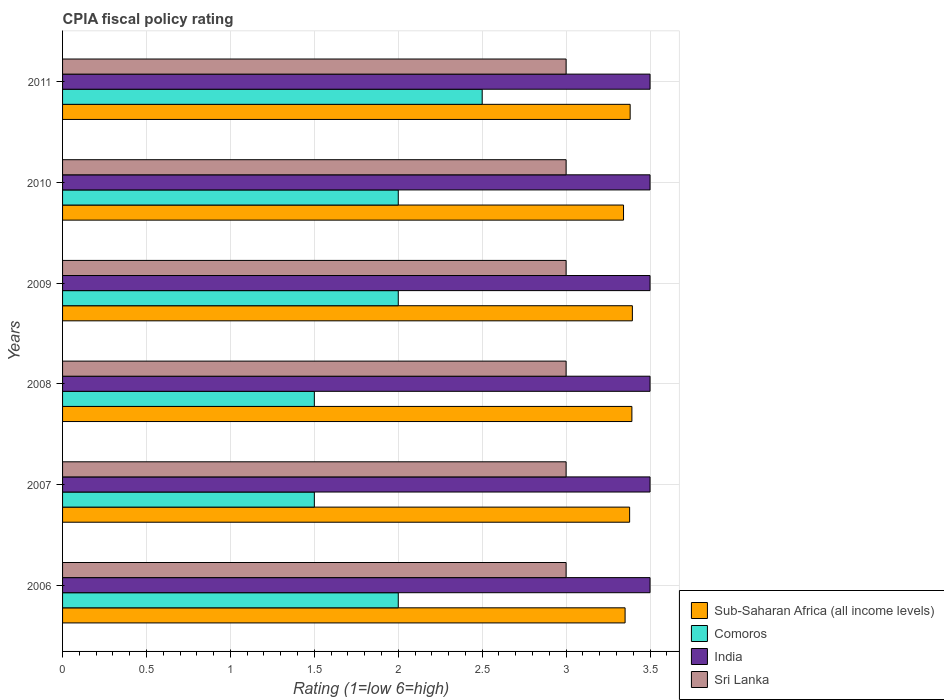Are the number of bars on each tick of the Y-axis equal?
Your response must be concise. Yes. How many bars are there on the 6th tick from the top?
Your answer should be very brief. 4. What is the CPIA rating in Sub-Saharan Africa (all income levels) in 2006?
Offer a very short reply. 3.35. Across all years, what is the minimum CPIA rating in Sri Lanka?
Provide a short and direct response. 3. What is the difference between the CPIA rating in Sri Lanka in 2007 and that in 2010?
Your response must be concise. 0. What is the difference between the CPIA rating in India in 2011 and the CPIA rating in Comoros in 2007?
Provide a succinct answer. 2. In the year 2011, what is the difference between the CPIA rating in Sub-Saharan Africa (all income levels) and CPIA rating in Sri Lanka?
Make the answer very short. 0.38. In how many years, is the CPIA rating in India greater than 0.30000000000000004 ?
Keep it short and to the point. 6. What is the ratio of the CPIA rating in Sri Lanka in 2008 to that in 2011?
Make the answer very short. 1. Is the CPIA rating in Sri Lanka in 2006 less than that in 2009?
Keep it short and to the point. No. What is the difference between the highest and the lowest CPIA rating in Sri Lanka?
Provide a succinct answer. 0. Is the sum of the CPIA rating in Sub-Saharan Africa (all income levels) in 2006 and 2007 greater than the maximum CPIA rating in Sri Lanka across all years?
Your answer should be compact. Yes. What does the 3rd bar from the top in 2006 represents?
Ensure brevity in your answer.  Comoros. What does the 4th bar from the bottom in 2009 represents?
Make the answer very short. Sri Lanka. Is it the case that in every year, the sum of the CPIA rating in Sri Lanka and CPIA rating in Comoros is greater than the CPIA rating in Sub-Saharan Africa (all income levels)?
Offer a very short reply. Yes. Are all the bars in the graph horizontal?
Your response must be concise. Yes. How many years are there in the graph?
Ensure brevity in your answer.  6. Where does the legend appear in the graph?
Your answer should be compact. Bottom right. How many legend labels are there?
Give a very brief answer. 4. What is the title of the graph?
Provide a succinct answer. CPIA fiscal policy rating. What is the label or title of the Y-axis?
Ensure brevity in your answer.  Years. What is the Rating (1=low 6=high) of Sub-Saharan Africa (all income levels) in 2006?
Give a very brief answer. 3.35. What is the Rating (1=low 6=high) of India in 2006?
Your response must be concise. 3.5. What is the Rating (1=low 6=high) of Sri Lanka in 2006?
Give a very brief answer. 3. What is the Rating (1=low 6=high) of Sub-Saharan Africa (all income levels) in 2007?
Keep it short and to the point. 3.38. What is the Rating (1=low 6=high) of Comoros in 2007?
Your answer should be compact. 1.5. What is the Rating (1=low 6=high) in India in 2007?
Ensure brevity in your answer.  3.5. What is the Rating (1=low 6=high) of Sri Lanka in 2007?
Provide a succinct answer. 3. What is the Rating (1=low 6=high) in Sub-Saharan Africa (all income levels) in 2008?
Your response must be concise. 3.39. What is the Rating (1=low 6=high) in Sub-Saharan Africa (all income levels) in 2009?
Keep it short and to the point. 3.39. What is the Rating (1=low 6=high) of Comoros in 2009?
Ensure brevity in your answer.  2. What is the Rating (1=low 6=high) of Sub-Saharan Africa (all income levels) in 2010?
Ensure brevity in your answer.  3.34. What is the Rating (1=low 6=high) in India in 2010?
Offer a terse response. 3.5. What is the Rating (1=low 6=high) of Sri Lanka in 2010?
Your answer should be compact. 3. What is the Rating (1=low 6=high) in Sub-Saharan Africa (all income levels) in 2011?
Your answer should be compact. 3.38. What is the Rating (1=low 6=high) of Comoros in 2011?
Offer a very short reply. 2.5. What is the Rating (1=low 6=high) in Sri Lanka in 2011?
Ensure brevity in your answer.  3. Across all years, what is the maximum Rating (1=low 6=high) in Sub-Saharan Africa (all income levels)?
Offer a terse response. 3.39. Across all years, what is the maximum Rating (1=low 6=high) of Sri Lanka?
Provide a short and direct response. 3. Across all years, what is the minimum Rating (1=low 6=high) of Sub-Saharan Africa (all income levels)?
Ensure brevity in your answer.  3.34. Across all years, what is the minimum Rating (1=low 6=high) in Comoros?
Your answer should be very brief. 1.5. What is the total Rating (1=low 6=high) in Sub-Saharan Africa (all income levels) in the graph?
Your response must be concise. 20.24. What is the total Rating (1=low 6=high) of India in the graph?
Ensure brevity in your answer.  21. What is the difference between the Rating (1=low 6=high) of Sub-Saharan Africa (all income levels) in 2006 and that in 2007?
Your response must be concise. -0.03. What is the difference between the Rating (1=low 6=high) in Comoros in 2006 and that in 2007?
Ensure brevity in your answer.  0.5. What is the difference between the Rating (1=low 6=high) of Sub-Saharan Africa (all income levels) in 2006 and that in 2008?
Provide a short and direct response. -0.04. What is the difference between the Rating (1=low 6=high) of Comoros in 2006 and that in 2008?
Ensure brevity in your answer.  0.5. What is the difference between the Rating (1=low 6=high) of India in 2006 and that in 2008?
Your answer should be very brief. 0. What is the difference between the Rating (1=low 6=high) in Sri Lanka in 2006 and that in 2008?
Ensure brevity in your answer.  0. What is the difference between the Rating (1=low 6=high) of Sub-Saharan Africa (all income levels) in 2006 and that in 2009?
Ensure brevity in your answer.  -0.04. What is the difference between the Rating (1=low 6=high) of Comoros in 2006 and that in 2009?
Your answer should be compact. 0. What is the difference between the Rating (1=low 6=high) of Sri Lanka in 2006 and that in 2009?
Give a very brief answer. 0. What is the difference between the Rating (1=low 6=high) in Sub-Saharan Africa (all income levels) in 2006 and that in 2010?
Provide a succinct answer. 0.01. What is the difference between the Rating (1=low 6=high) of Comoros in 2006 and that in 2010?
Provide a short and direct response. 0. What is the difference between the Rating (1=low 6=high) in Sub-Saharan Africa (all income levels) in 2006 and that in 2011?
Provide a short and direct response. -0.03. What is the difference between the Rating (1=low 6=high) of Comoros in 2006 and that in 2011?
Provide a short and direct response. -0.5. What is the difference between the Rating (1=low 6=high) of India in 2006 and that in 2011?
Provide a short and direct response. 0. What is the difference between the Rating (1=low 6=high) of Sub-Saharan Africa (all income levels) in 2007 and that in 2008?
Offer a very short reply. -0.01. What is the difference between the Rating (1=low 6=high) in Comoros in 2007 and that in 2008?
Your answer should be compact. 0. What is the difference between the Rating (1=low 6=high) of Sri Lanka in 2007 and that in 2008?
Ensure brevity in your answer.  0. What is the difference between the Rating (1=low 6=high) in Sub-Saharan Africa (all income levels) in 2007 and that in 2009?
Your answer should be very brief. -0.02. What is the difference between the Rating (1=low 6=high) in Comoros in 2007 and that in 2009?
Offer a terse response. -0.5. What is the difference between the Rating (1=low 6=high) of Sub-Saharan Africa (all income levels) in 2007 and that in 2010?
Offer a very short reply. 0.04. What is the difference between the Rating (1=low 6=high) in Sub-Saharan Africa (all income levels) in 2007 and that in 2011?
Provide a short and direct response. -0. What is the difference between the Rating (1=low 6=high) of Comoros in 2007 and that in 2011?
Offer a terse response. -1. What is the difference between the Rating (1=low 6=high) in Sub-Saharan Africa (all income levels) in 2008 and that in 2009?
Your response must be concise. -0. What is the difference between the Rating (1=low 6=high) in Comoros in 2008 and that in 2009?
Provide a succinct answer. -0.5. What is the difference between the Rating (1=low 6=high) of India in 2008 and that in 2009?
Provide a short and direct response. 0. What is the difference between the Rating (1=low 6=high) of Sri Lanka in 2008 and that in 2009?
Offer a very short reply. 0. What is the difference between the Rating (1=low 6=high) of Sub-Saharan Africa (all income levels) in 2008 and that in 2010?
Keep it short and to the point. 0.05. What is the difference between the Rating (1=low 6=high) of Comoros in 2008 and that in 2010?
Provide a short and direct response. -0.5. What is the difference between the Rating (1=low 6=high) in Sub-Saharan Africa (all income levels) in 2008 and that in 2011?
Offer a very short reply. 0.01. What is the difference between the Rating (1=low 6=high) in Comoros in 2008 and that in 2011?
Give a very brief answer. -1. What is the difference between the Rating (1=low 6=high) in Sub-Saharan Africa (all income levels) in 2009 and that in 2010?
Your response must be concise. 0.05. What is the difference between the Rating (1=low 6=high) of Comoros in 2009 and that in 2010?
Ensure brevity in your answer.  0. What is the difference between the Rating (1=low 6=high) in India in 2009 and that in 2010?
Make the answer very short. 0. What is the difference between the Rating (1=low 6=high) in Sub-Saharan Africa (all income levels) in 2009 and that in 2011?
Your answer should be very brief. 0.01. What is the difference between the Rating (1=low 6=high) of Sub-Saharan Africa (all income levels) in 2010 and that in 2011?
Your response must be concise. -0.04. What is the difference between the Rating (1=low 6=high) in Comoros in 2010 and that in 2011?
Offer a terse response. -0.5. What is the difference between the Rating (1=low 6=high) of Sri Lanka in 2010 and that in 2011?
Offer a terse response. 0. What is the difference between the Rating (1=low 6=high) of Sub-Saharan Africa (all income levels) in 2006 and the Rating (1=low 6=high) of Comoros in 2007?
Your answer should be very brief. 1.85. What is the difference between the Rating (1=low 6=high) in Sub-Saharan Africa (all income levels) in 2006 and the Rating (1=low 6=high) in India in 2007?
Keep it short and to the point. -0.15. What is the difference between the Rating (1=low 6=high) of Sub-Saharan Africa (all income levels) in 2006 and the Rating (1=low 6=high) of Sri Lanka in 2007?
Your response must be concise. 0.35. What is the difference between the Rating (1=low 6=high) of Comoros in 2006 and the Rating (1=low 6=high) of India in 2007?
Make the answer very short. -1.5. What is the difference between the Rating (1=low 6=high) of Sub-Saharan Africa (all income levels) in 2006 and the Rating (1=low 6=high) of Comoros in 2008?
Provide a short and direct response. 1.85. What is the difference between the Rating (1=low 6=high) in Sub-Saharan Africa (all income levels) in 2006 and the Rating (1=low 6=high) in India in 2008?
Offer a very short reply. -0.15. What is the difference between the Rating (1=low 6=high) in Sub-Saharan Africa (all income levels) in 2006 and the Rating (1=low 6=high) in Sri Lanka in 2008?
Your answer should be compact. 0.35. What is the difference between the Rating (1=low 6=high) in Comoros in 2006 and the Rating (1=low 6=high) in India in 2008?
Make the answer very short. -1.5. What is the difference between the Rating (1=low 6=high) in Comoros in 2006 and the Rating (1=low 6=high) in Sri Lanka in 2008?
Your answer should be compact. -1. What is the difference between the Rating (1=low 6=high) of India in 2006 and the Rating (1=low 6=high) of Sri Lanka in 2008?
Your answer should be very brief. 0.5. What is the difference between the Rating (1=low 6=high) of Sub-Saharan Africa (all income levels) in 2006 and the Rating (1=low 6=high) of Comoros in 2009?
Your response must be concise. 1.35. What is the difference between the Rating (1=low 6=high) of Sub-Saharan Africa (all income levels) in 2006 and the Rating (1=low 6=high) of India in 2009?
Offer a very short reply. -0.15. What is the difference between the Rating (1=low 6=high) of Sub-Saharan Africa (all income levels) in 2006 and the Rating (1=low 6=high) of Sri Lanka in 2009?
Your answer should be compact. 0.35. What is the difference between the Rating (1=low 6=high) in Comoros in 2006 and the Rating (1=low 6=high) in Sri Lanka in 2009?
Provide a succinct answer. -1. What is the difference between the Rating (1=low 6=high) in India in 2006 and the Rating (1=low 6=high) in Sri Lanka in 2009?
Provide a short and direct response. 0.5. What is the difference between the Rating (1=low 6=high) in Sub-Saharan Africa (all income levels) in 2006 and the Rating (1=low 6=high) in Comoros in 2010?
Your answer should be compact. 1.35. What is the difference between the Rating (1=low 6=high) of Sub-Saharan Africa (all income levels) in 2006 and the Rating (1=low 6=high) of India in 2010?
Offer a terse response. -0.15. What is the difference between the Rating (1=low 6=high) of Sub-Saharan Africa (all income levels) in 2006 and the Rating (1=low 6=high) of Sri Lanka in 2010?
Your answer should be very brief. 0.35. What is the difference between the Rating (1=low 6=high) in Comoros in 2006 and the Rating (1=low 6=high) in India in 2010?
Your answer should be very brief. -1.5. What is the difference between the Rating (1=low 6=high) in Comoros in 2006 and the Rating (1=low 6=high) in Sri Lanka in 2010?
Give a very brief answer. -1. What is the difference between the Rating (1=low 6=high) in Sub-Saharan Africa (all income levels) in 2006 and the Rating (1=low 6=high) in Comoros in 2011?
Your answer should be compact. 0.85. What is the difference between the Rating (1=low 6=high) of Sub-Saharan Africa (all income levels) in 2006 and the Rating (1=low 6=high) of India in 2011?
Provide a short and direct response. -0.15. What is the difference between the Rating (1=low 6=high) in Sub-Saharan Africa (all income levels) in 2006 and the Rating (1=low 6=high) in Sri Lanka in 2011?
Make the answer very short. 0.35. What is the difference between the Rating (1=low 6=high) of India in 2006 and the Rating (1=low 6=high) of Sri Lanka in 2011?
Keep it short and to the point. 0.5. What is the difference between the Rating (1=low 6=high) of Sub-Saharan Africa (all income levels) in 2007 and the Rating (1=low 6=high) of Comoros in 2008?
Offer a very short reply. 1.88. What is the difference between the Rating (1=low 6=high) of Sub-Saharan Africa (all income levels) in 2007 and the Rating (1=low 6=high) of India in 2008?
Make the answer very short. -0.12. What is the difference between the Rating (1=low 6=high) in Sub-Saharan Africa (all income levels) in 2007 and the Rating (1=low 6=high) in Sri Lanka in 2008?
Your answer should be compact. 0.38. What is the difference between the Rating (1=low 6=high) of Comoros in 2007 and the Rating (1=low 6=high) of Sri Lanka in 2008?
Provide a succinct answer. -1.5. What is the difference between the Rating (1=low 6=high) of India in 2007 and the Rating (1=low 6=high) of Sri Lanka in 2008?
Your answer should be very brief. 0.5. What is the difference between the Rating (1=low 6=high) in Sub-Saharan Africa (all income levels) in 2007 and the Rating (1=low 6=high) in Comoros in 2009?
Give a very brief answer. 1.38. What is the difference between the Rating (1=low 6=high) of Sub-Saharan Africa (all income levels) in 2007 and the Rating (1=low 6=high) of India in 2009?
Provide a succinct answer. -0.12. What is the difference between the Rating (1=low 6=high) in Sub-Saharan Africa (all income levels) in 2007 and the Rating (1=low 6=high) in Sri Lanka in 2009?
Provide a succinct answer. 0.38. What is the difference between the Rating (1=low 6=high) of Comoros in 2007 and the Rating (1=low 6=high) of Sri Lanka in 2009?
Your answer should be very brief. -1.5. What is the difference between the Rating (1=low 6=high) in Sub-Saharan Africa (all income levels) in 2007 and the Rating (1=low 6=high) in Comoros in 2010?
Ensure brevity in your answer.  1.38. What is the difference between the Rating (1=low 6=high) in Sub-Saharan Africa (all income levels) in 2007 and the Rating (1=low 6=high) in India in 2010?
Your answer should be compact. -0.12. What is the difference between the Rating (1=low 6=high) of Sub-Saharan Africa (all income levels) in 2007 and the Rating (1=low 6=high) of Sri Lanka in 2010?
Give a very brief answer. 0.38. What is the difference between the Rating (1=low 6=high) in Comoros in 2007 and the Rating (1=low 6=high) in Sri Lanka in 2010?
Your answer should be very brief. -1.5. What is the difference between the Rating (1=low 6=high) in India in 2007 and the Rating (1=low 6=high) in Sri Lanka in 2010?
Offer a very short reply. 0.5. What is the difference between the Rating (1=low 6=high) of Sub-Saharan Africa (all income levels) in 2007 and the Rating (1=low 6=high) of Comoros in 2011?
Provide a short and direct response. 0.88. What is the difference between the Rating (1=low 6=high) of Sub-Saharan Africa (all income levels) in 2007 and the Rating (1=low 6=high) of India in 2011?
Ensure brevity in your answer.  -0.12. What is the difference between the Rating (1=low 6=high) of Sub-Saharan Africa (all income levels) in 2007 and the Rating (1=low 6=high) of Sri Lanka in 2011?
Give a very brief answer. 0.38. What is the difference between the Rating (1=low 6=high) in Comoros in 2007 and the Rating (1=low 6=high) in India in 2011?
Your answer should be compact. -2. What is the difference between the Rating (1=low 6=high) in India in 2007 and the Rating (1=low 6=high) in Sri Lanka in 2011?
Ensure brevity in your answer.  0.5. What is the difference between the Rating (1=low 6=high) of Sub-Saharan Africa (all income levels) in 2008 and the Rating (1=low 6=high) of Comoros in 2009?
Keep it short and to the point. 1.39. What is the difference between the Rating (1=low 6=high) of Sub-Saharan Africa (all income levels) in 2008 and the Rating (1=low 6=high) of India in 2009?
Your answer should be very brief. -0.11. What is the difference between the Rating (1=low 6=high) of Sub-Saharan Africa (all income levels) in 2008 and the Rating (1=low 6=high) of Sri Lanka in 2009?
Keep it short and to the point. 0.39. What is the difference between the Rating (1=low 6=high) of Comoros in 2008 and the Rating (1=low 6=high) of Sri Lanka in 2009?
Provide a short and direct response. -1.5. What is the difference between the Rating (1=low 6=high) in Sub-Saharan Africa (all income levels) in 2008 and the Rating (1=low 6=high) in Comoros in 2010?
Your answer should be compact. 1.39. What is the difference between the Rating (1=low 6=high) of Sub-Saharan Africa (all income levels) in 2008 and the Rating (1=low 6=high) of India in 2010?
Offer a very short reply. -0.11. What is the difference between the Rating (1=low 6=high) of Sub-Saharan Africa (all income levels) in 2008 and the Rating (1=low 6=high) of Sri Lanka in 2010?
Offer a very short reply. 0.39. What is the difference between the Rating (1=low 6=high) in Comoros in 2008 and the Rating (1=low 6=high) in India in 2010?
Keep it short and to the point. -2. What is the difference between the Rating (1=low 6=high) in Comoros in 2008 and the Rating (1=low 6=high) in Sri Lanka in 2010?
Provide a short and direct response. -1.5. What is the difference between the Rating (1=low 6=high) of India in 2008 and the Rating (1=low 6=high) of Sri Lanka in 2010?
Keep it short and to the point. 0.5. What is the difference between the Rating (1=low 6=high) of Sub-Saharan Africa (all income levels) in 2008 and the Rating (1=low 6=high) of Comoros in 2011?
Provide a short and direct response. 0.89. What is the difference between the Rating (1=low 6=high) in Sub-Saharan Africa (all income levels) in 2008 and the Rating (1=low 6=high) in India in 2011?
Provide a short and direct response. -0.11. What is the difference between the Rating (1=low 6=high) in Sub-Saharan Africa (all income levels) in 2008 and the Rating (1=low 6=high) in Sri Lanka in 2011?
Your response must be concise. 0.39. What is the difference between the Rating (1=low 6=high) of India in 2008 and the Rating (1=low 6=high) of Sri Lanka in 2011?
Make the answer very short. 0.5. What is the difference between the Rating (1=low 6=high) in Sub-Saharan Africa (all income levels) in 2009 and the Rating (1=low 6=high) in Comoros in 2010?
Offer a very short reply. 1.39. What is the difference between the Rating (1=low 6=high) of Sub-Saharan Africa (all income levels) in 2009 and the Rating (1=low 6=high) of India in 2010?
Your answer should be very brief. -0.11. What is the difference between the Rating (1=low 6=high) in Sub-Saharan Africa (all income levels) in 2009 and the Rating (1=low 6=high) in Sri Lanka in 2010?
Keep it short and to the point. 0.39. What is the difference between the Rating (1=low 6=high) in Comoros in 2009 and the Rating (1=low 6=high) in India in 2010?
Provide a short and direct response. -1.5. What is the difference between the Rating (1=low 6=high) of Sub-Saharan Africa (all income levels) in 2009 and the Rating (1=low 6=high) of Comoros in 2011?
Your answer should be compact. 0.89. What is the difference between the Rating (1=low 6=high) of Sub-Saharan Africa (all income levels) in 2009 and the Rating (1=low 6=high) of India in 2011?
Make the answer very short. -0.11. What is the difference between the Rating (1=low 6=high) of Sub-Saharan Africa (all income levels) in 2009 and the Rating (1=low 6=high) of Sri Lanka in 2011?
Provide a succinct answer. 0.39. What is the difference between the Rating (1=low 6=high) of Sub-Saharan Africa (all income levels) in 2010 and the Rating (1=low 6=high) of Comoros in 2011?
Your answer should be compact. 0.84. What is the difference between the Rating (1=low 6=high) in Sub-Saharan Africa (all income levels) in 2010 and the Rating (1=low 6=high) in India in 2011?
Keep it short and to the point. -0.16. What is the difference between the Rating (1=low 6=high) of Sub-Saharan Africa (all income levels) in 2010 and the Rating (1=low 6=high) of Sri Lanka in 2011?
Your answer should be very brief. 0.34. What is the difference between the Rating (1=low 6=high) of Comoros in 2010 and the Rating (1=low 6=high) of Sri Lanka in 2011?
Offer a very short reply. -1. What is the difference between the Rating (1=low 6=high) in India in 2010 and the Rating (1=low 6=high) in Sri Lanka in 2011?
Provide a succinct answer. 0.5. What is the average Rating (1=low 6=high) in Sub-Saharan Africa (all income levels) per year?
Ensure brevity in your answer.  3.37. What is the average Rating (1=low 6=high) in Comoros per year?
Give a very brief answer. 1.92. What is the average Rating (1=low 6=high) of India per year?
Your response must be concise. 3.5. In the year 2006, what is the difference between the Rating (1=low 6=high) in Sub-Saharan Africa (all income levels) and Rating (1=low 6=high) in Comoros?
Your answer should be compact. 1.35. In the year 2006, what is the difference between the Rating (1=low 6=high) in Sub-Saharan Africa (all income levels) and Rating (1=low 6=high) in India?
Ensure brevity in your answer.  -0.15. In the year 2006, what is the difference between the Rating (1=low 6=high) in Sub-Saharan Africa (all income levels) and Rating (1=low 6=high) in Sri Lanka?
Provide a short and direct response. 0.35. In the year 2006, what is the difference between the Rating (1=low 6=high) in Comoros and Rating (1=low 6=high) in Sri Lanka?
Give a very brief answer. -1. In the year 2006, what is the difference between the Rating (1=low 6=high) in India and Rating (1=low 6=high) in Sri Lanka?
Ensure brevity in your answer.  0.5. In the year 2007, what is the difference between the Rating (1=low 6=high) of Sub-Saharan Africa (all income levels) and Rating (1=low 6=high) of Comoros?
Your answer should be very brief. 1.88. In the year 2007, what is the difference between the Rating (1=low 6=high) in Sub-Saharan Africa (all income levels) and Rating (1=low 6=high) in India?
Ensure brevity in your answer.  -0.12. In the year 2007, what is the difference between the Rating (1=low 6=high) of Sub-Saharan Africa (all income levels) and Rating (1=low 6=high) of Sri Lanka?
Your answer should be very brief. 0.38. In the year 2008, what is the difference between the Rating (1=low 6=high) in Sub-Saharan Africa (all income levels) and Rating (1=low 6=high) in Comoros?
Ensure brevity in your answer.  1.89. In the year 2008, what is the difference between the Rating (1=low 6=high) in Sub-Saharan Africa (all income levels) and Rating (1=low 6=high) in India?
Provide a short and direct response. -0.11. In the year 2008, what is the difference between the Rating (1=low 6=high) in Sub-Saharan Africa (all income levels) and Rating (1=low 6=high) in Sri Lanka?
Keep it short and to the point. 0.39. In the year 2008, what is the difference between the Rating (1=low 6=high) in Comoros and Rating (1=low 6=high) in India?
Make the answer very short. -2. In the year 2009, what is the difference between the Rating (1=low 6=high) in Sub-Saharan Africa (all income levels) and Rating (1=low 6=high) in Comoros?
Give a very brief answer. 1.39. In the year 2009, what is the difference between the Rating (1=low 6=high) of Sub-Saharan Africa (all income levels) and Rating (1=low 6=high) of India?
Give a very brief answer. -0.11. In the year 2009, what is the difference between the Rating (1=low 6=high) of Sub-Saharan Africa (all income levels) and Rating (1=low 6=high) of Sri Lanka?
Offer a very short reply. 0.39. In the year 2009, what is the difference between the Rating (1=low 6=high) in Comoros and Rating (1=low 6=high) in India?
Make the answer very short. -1.5. In the year 2010, what is the difference between the Rating (1=low 6=high) in Sub-Saharan Africa (all income levels) and Rating (1=low 6=high) in Comoros?
Provide a succinct answer. 1.34. In the year 2010, what is the difference between the Rating (1=low 6=high) of Sub-Saharan Africa (all income levels) and Rating (1=low 6=high) of India?
Provide a short and direct response. -0.16. In the year 2010, what is the difference between the Rating (1=low 6=high) of Sub-Saharan Africa (all income levels) and Rating (1=low 6=high) of Sri Lanka?
Keep it short and to the point. 0.34. In the year 2010, what is the difference between the Rating (1=low 6=high) in Comoros and Rating (1=low 6=high) in Sri Lanka?
Make the answer very short. -1. In the year 2011, what is the difference between the Rating (1=low 6=high) in Sub-Saharan Africa (all income levels) and Rating (1=low 6=high) in Comoros?
Give a very brief answer. 0.88. In the year 2011, what is the difference between the Rating (1=low 6=high) in Sub-Saharan Africa (all income levels) and Rating (1=low 6=high) in India?
Provide a succinct answer. -0.12. In the year 2011, what is the difference between the Rating (1=low 6=high) in Sub-Saharan Africa (all income levels) and Rating (1=low 6=high) in Sri Lanka?
Keep it short and to the point. 0.38. In the year 2011, what is the difference between the Rating (1=low 6=high) in Comoros and Rating (1=low 6=high) in India?
Give a very brief answer. -1. What is the ratio of the Rating (1=low 6=high) of Comoros in 2006 to that in 2008?
Make the answer very short. 1.33. What is the ratio of the Rating (1=low 6=high) of Sub-Saharan Africa (all income levels) in 2006 to that in 2009?
Give a very brief answer. 0.99. What is the ratio of the Rating (1=low 6=high) of India in 2006 to that in 2009?
Your answer should be compact. 1. What is the ratio of the Rating (1=low 6=high) in Sri Lanka in 2006 to that in 2009?
Keep it short and to the point. 1. What is the ratio of the Rating (1=low 6=high) in Sub-Saharan Africa (all income levels) in 2006 to that in 2010?
Your answer should be compact. 1. What is the ratio of the Rating (1=low 6=high) in India in 2006 to that in 2010?
Keep it short and to the point. 1. What is the ratio of the Rating (1=low 6=high) in Sri Lanka in 2006 to that in 2010?
Keep it short and to the point. 1. What is the ratio of the Rating (1=low 6=high) in Sub-Saharan Africa (all income levels) in 2006 to that in 2011?
Your answer should be very brief. 0.99. What is the ratio of the Rating (1=low 6=high) in Sri Lanka in 2006 to that in 2011?
Provide a succinct answer. 1. What is the ratio of the Rating (1=low 6=high) in Comoros in 2007 to that in 2008?
Your response must be concise. 1. What is the ratio of the Rating (1=low 6=high) of Sri Lanka in 2007 to that in 2008?
Your answer should be very brief. 1. What is the ratio of the Rating (1=low 6=high) of Sub-Saharan Africa (all income levels) in 2007 to that in 2009?
Your answer should be very brief. 1. What is the ratio of the Rating (1=low 6=high) in Comoros in 2007 to that in 2009?
Offer a very short reply. 0.75. What is the ratio of the Rating (1=low 6=high) in Sub-Saharan Africa (all income levels) in 2007 to that in 2010?
Your answer should be compact. 1.01. What is the ratio of the Rating (1=low 6=high) in Sri Lanka in 2007 to that in 2010?
Provide a succinct answer. 1. What is the ratio of the Rating (1=low 6=high) of India in 2007 to that in 2011?
Ensure brevity in your answer.  1. What is the ratio of the Rating (1=low 6=high) in Sub-Saharan Africa (all income levels) in 2008 to that in 2009?
Your response must be concise. 1. What is the ratio of the Rating (1=low 6=high) in Comoros in 2008 to that in 2009?
Offer a terse response. 0.75. What is the ratio of the Rating (1=low 6=high) in India in 2008 to that in 2009?
Keep it short and to the point. 1. What is the ratio of the Rating (1=low 6=high) in Sri Lanka in 2008 to that in 2009?
Provide a succinct answer. 1. What is the ratio of the Rating (1=low 6=high) in Sub-Saharan Africa (all income levels) in 2008 to that in 2010?
Give a very brief answer. 1.01. What is the ratio of the Rating (1=low 6=high) in Comoros in 2008 to that in 2010?
Keep it short and to the point. 0.75. What is the ratio of the Rating (1=low 6=high) in Sub-Saharan Africa (all income levels) in 2008 to that in 2011?
Ensure brevity in your answer.  1. What is the ratio of the Rating (1=low 6=high) in Comoros in 2008 to that in 2011?
Provide a short and direct response. 0.6. What is the ratio of the Rating (1=low 6=high) of Sub-Saharan Africa (all income levels) in 2009 to that in 2010?
Give a very brief answer. 1.02. What is the ratio of the Rating (1=low 6=high) of Comoros in 2009 to that in 2010?
Offer a terse response. 1. What is the ratio of the Rating (1=low 6=high) in India in 2009 to that in 2010?
Your answer should be very brief. 1. What is the ratio of the Rating (1=low 6=high) in Sub-Saharan Africa (all income levels) in 2009 to that in 2011?
Make the answer very short. 1. What is the ratio of the Rating (1=low 6=high) of Comoros in 2009 to that in 2011?
Offer a very short reply. 0.8. What is the ratio of the Rating (1=low 6=high) in Sri Lanka in 2009 to that in 2011?
Ensure brevity in your answer.  1. What is the ratio of the Rating (1=low 6=high) of Sub-Saharan Africa (all income levels) in 2010 to that in 2011?
Ensure brevity in your answer.  0.99. What is the ratio of the Rating (1=low 6=high) of Comoros in 2010 to that in 2011?
Make the answer very short. 0.8. What is the ratio of the Rating (1=low 6=high) of India in 2010 to that in 2011?
Your answer should be very brief. 1. What is the ratio of the Rating (1=low 6=high) of Sri Lanka in 2010 to that in 2011?
Offer a very short reply. 1. What is the difference between the highest and the second highest Rating (1=low 6=high) in Sub-Saharan Africa (all income levels)?
Your answer should be compact. 0. What is the difference between the highest and the second highest Rating (1=low 6=high) of India?
Your answer should be very brief. 0. What is the difference between the highest and the lowest Rating (1=low 6=high) of Sub-Saharan Africa (all income levels)?
Your answer should be very brief. 0.05. 